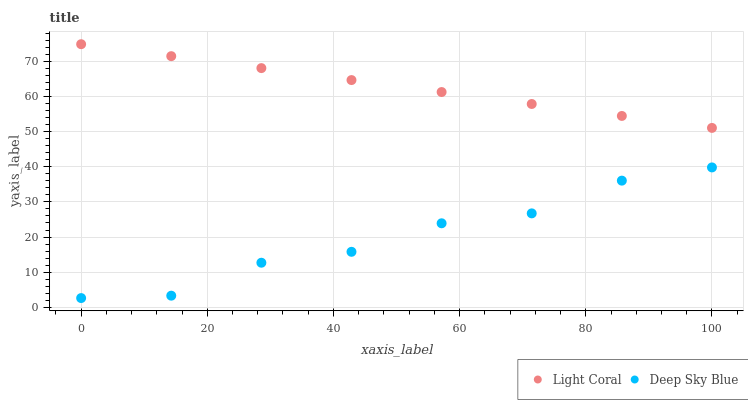Does Deep Sky Blue have the minimum area under the curve?
Answer yes or no. Yes. Does Light Coral have the maximum area under the curve?
Answer yes or no. Yes. Does Deep Sky Blue have the maximum area under the curve?
Answer yes or no. No. Is Light Coral the smoothest?
Answer yes or no. Yes. Is Deep Sky Blue the roughest?
Answer yes or no. Yes. Is Deep Sky Blue the smoothest?
Answer yes or no. No. Does Deep Sky Blue have the lowest value?
Answer yes or no. Yes. Does Light Coral have the highest value?
Answer yes or no. Yes. Does Deep Sky Blue have the highest value?
Answer yes or no. No. Is Deep Sky Blue less than Light Coral?
Answer yes or no. Yes. Is Light Coral greater than Deep Sky Blue?
Answer yes or no. Yes. Does Deep Sky Blue intersect Light Coral?
Answer yes or no. No. 